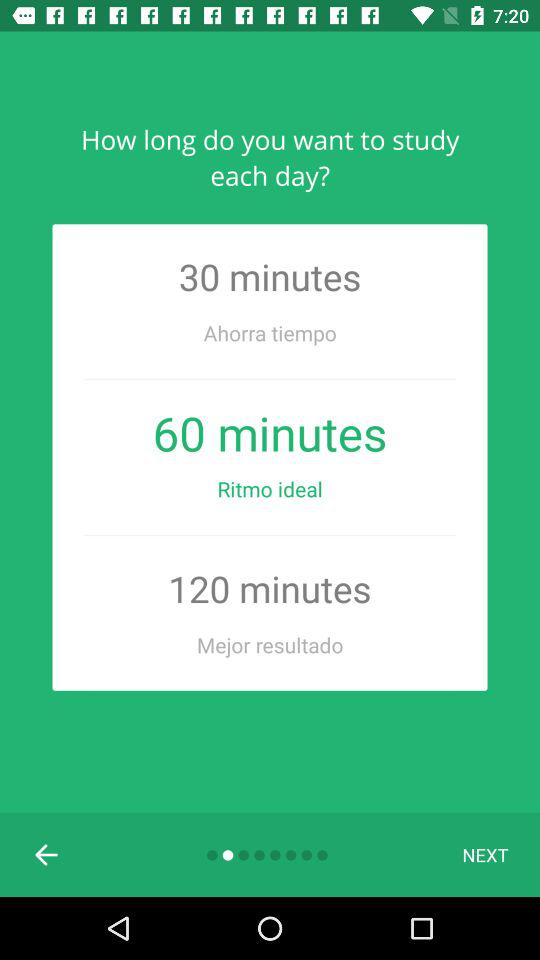What is the selected time duration? The selected time duration is 60 minutes. 